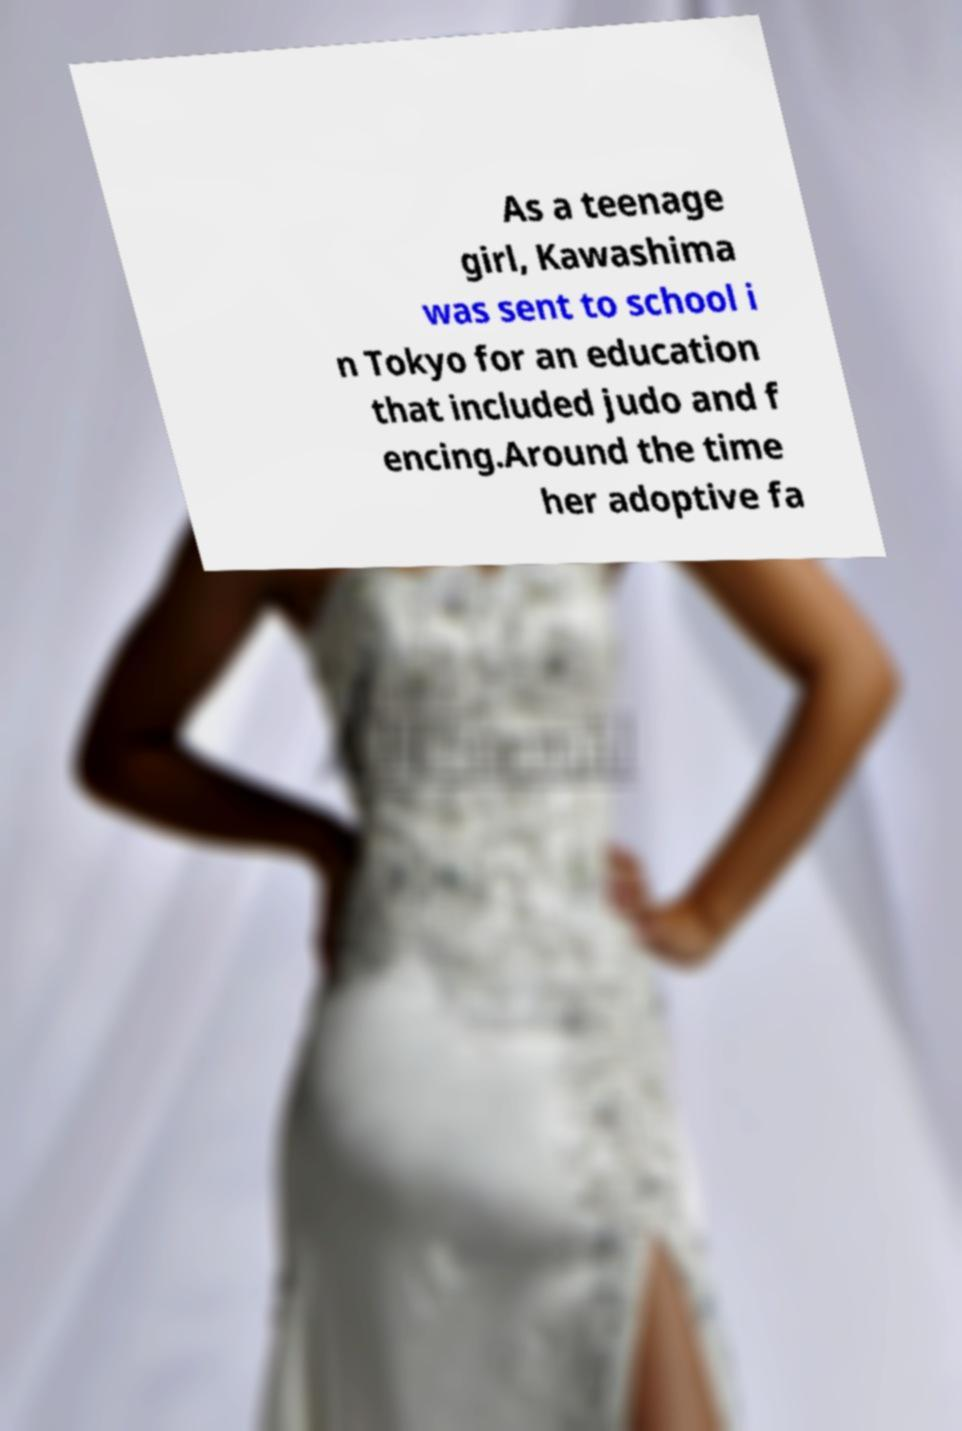Can you accurately transcribe the text from the provided image for me? As a teenage girl, Kawashima was sent to school i n Tokyo for an education that included judo and f encing.Around the time her adoptive fa 